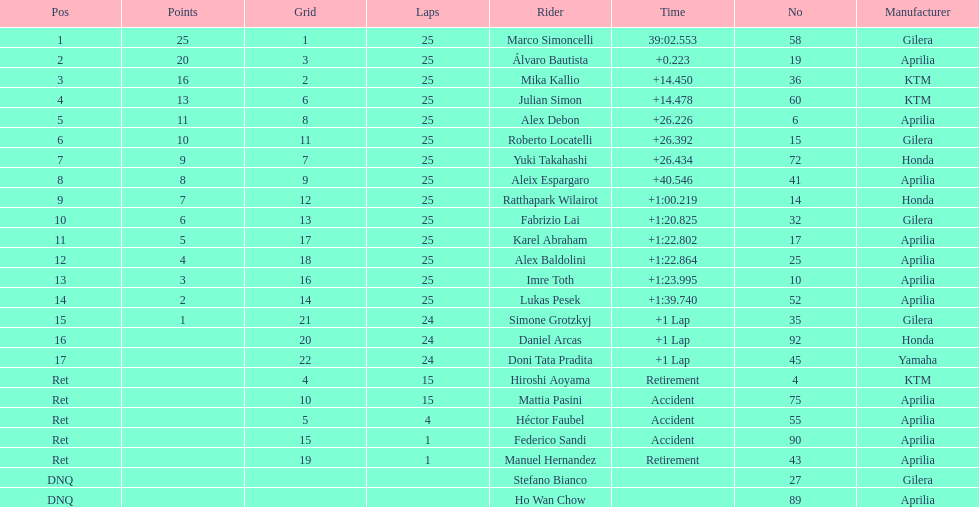Who were all of the riders? Marco Simoncelli, Álvaro Bautista, Mika Kallio, Julian Simon, Alex Debon, Roberto Locatelli, Yuki Takahashi, Aleix Espargaro, Ratthapark Wilairot, Fabrizio Lai, Karel Abraham, Alex Baldolini, Imre Toth, Lukas Pesek, Simone Grotzkyj, Daniel Arcas, Doni Tata Pradita, Hiroshi Aoyama, Mattia Pasini, Héctor Faubel, Federico Sandi, Manuel Hernandez, Stefano Bianco, Ho Wan Chow. How many laps did they complete? 25, 25, 25, 25, 25, 25, 25, 25, 25, 25, 25, 25, 25, 25, 24, 24, 24, 15, 15, 4, 1, 1, , . Between marco simoncelli and hiroshi aoyama, who had more laps? Marco Simoncelli. 